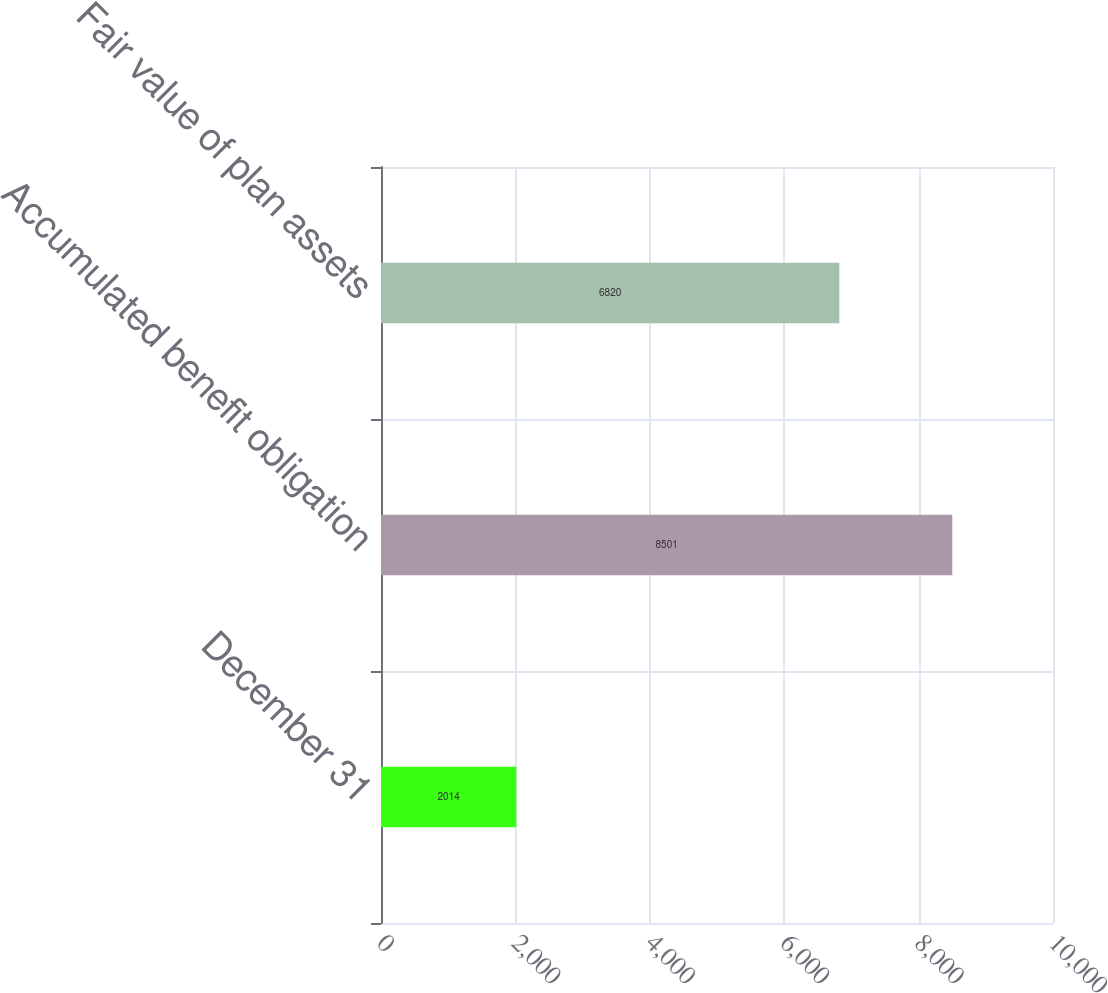Convert chart to OTSL. <chart><loc_0><loc_0><loc_500><loc_500><bar_chart><fcel>December 31<fcel>Accumulated benefit obligation<fcel>Fair value of plan assets<nl><fcel>2014<fcel>8501<fcel>6820<nl></chart> 